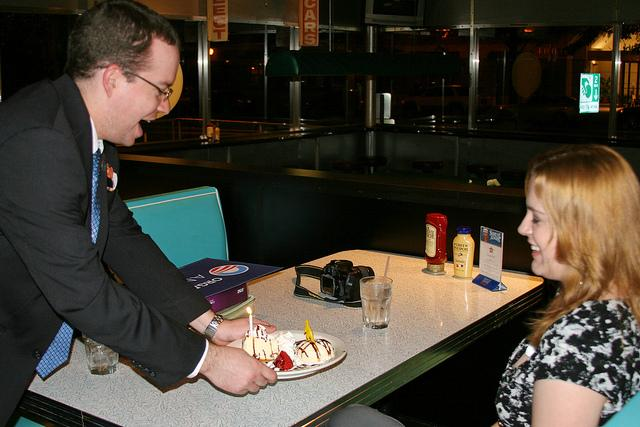Why is there a candle in the woman's dessert?

Choices:
A) to trick
B) to celebrate
C) as joke
D) for light to celebrate 